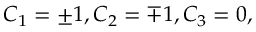Convert formula to latex. <formula><loc_0><loc_0><loc_500><loc_500>C _ { 1 } = \pm 1 , C _ { 2 } = \mp 1 , C _ { 3 } = 0 ,</formula> 